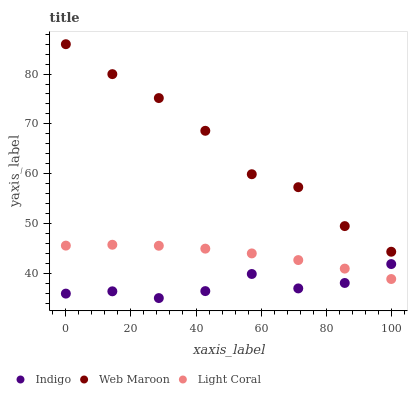Does Indigo have the minimum area under the curve?
Answer yes or no. Yes. Does Web Maroon have the maximum area under the curve?
Answer yes or no. Yes. Does Web Maroon have the minimum area under the curve?
Answer yes or no. No. Does Indigo have the maximum area under the curve?
Answer yes or no. No. Is Light Coral the smoothest?
Answer yes or no. Yes. Is Indigo the roughest?
Answer yes or no. Yes. Is Web Maroon the smoothest?
Answer yes or no. No. Is Web Maroon the roughest?
Answer yes or no. No. Does Indigo have the lowest value?
Answer yes or no. Yes. Does Web Maroon have the lowest value?
Answer yes or no. No. Does Web Maroon have the highest value?
Answer yes or no. Yes. Does Indigo have the highest value?
Answer yes or no. No. Is Indigo less than Web Maroon?
Answer yes or no. Yes. Is Web Maroon greater than Indigo?
Answer yes or no. Yes. Does Indigo intersect Light Coral?
Answer yes or no. Yes. Is Indigo less than Light Coral?
Answer yes or no. No. Is Indigo greater than Light Coral?
Answer yes or no. No. Does Indigo intersect Web Maroon?
Answer yes or no. No. 